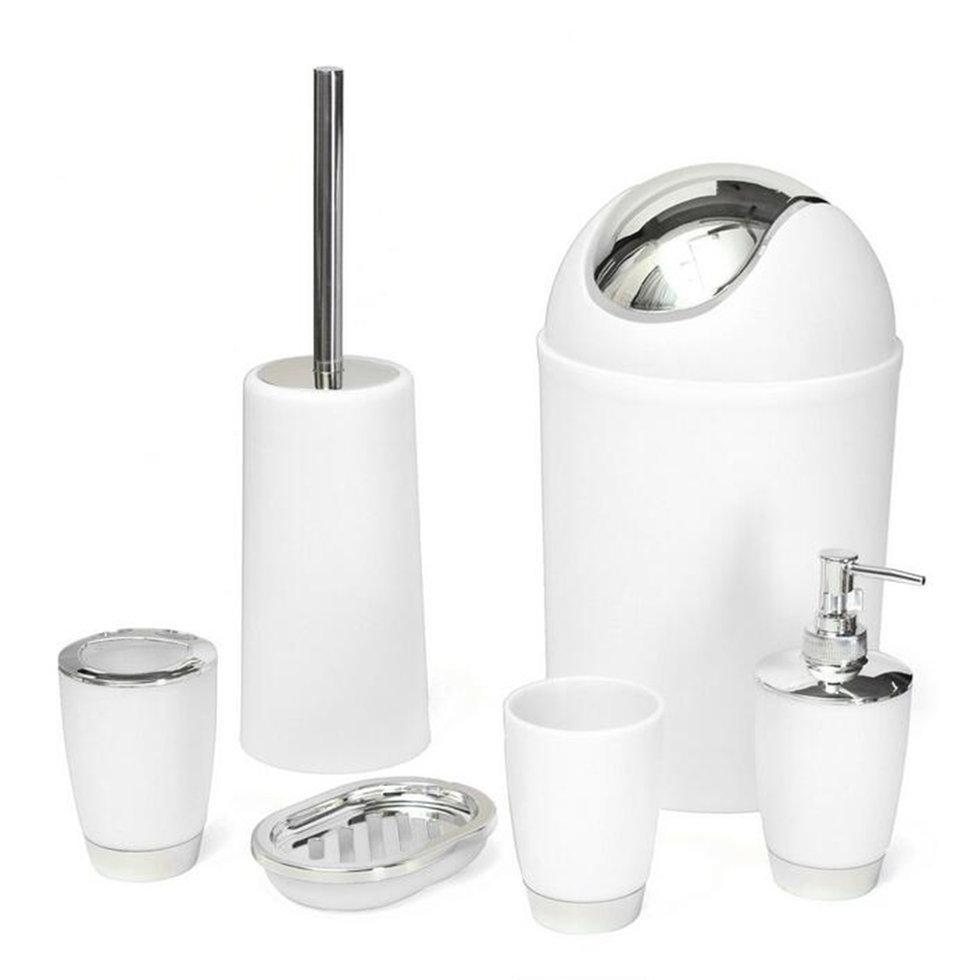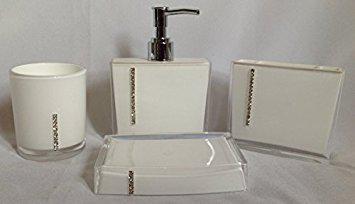The first image is the image on the left, the second image is the image on the right. Considering the images on both sides, is "The image on the right contains a grouping of four containers with a pump in the center of the back row of three." valid? Answer yes or no. Yes. 